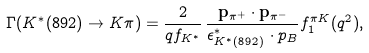<formula> <loc_0><loc_0><loc_500><loc_500>\Gamma ( K ^ { * } ( 8 9 2 ) \to K \pi ) = \frac { 2 } { q f _ { K ^ { * } } } \, \frac { { \mathbf p } _ { \pi ^ { + } } \cdot { \mathbf p } _ { \pi ^ { - } } } { \epsilon _ { K ^ { * } ( 8 9 2 ) } ^ { * } \, \cdot p _ { B } } f _ { 1 } ^ { \pi K } ( q ^ { 2 } ) ,</formula> 